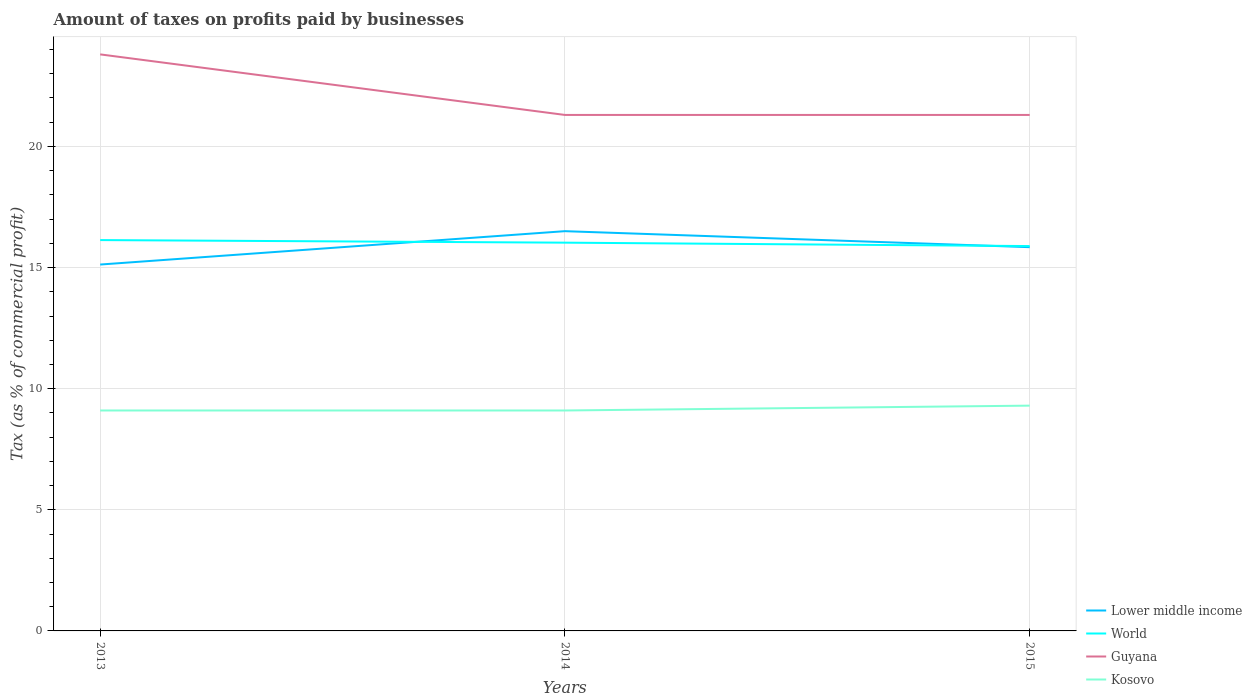Is the number of lines equal to the number of legend labels?
Your response must be concise. Yes. Across all years, what is the maximum percentage of taxes paid by businesses in Guyana?
Give a very brief answer. 21.3. What is the total percentage of taxes paid by businesses in Lower middle income in the graph?
Provide a succinct answer. 0.66. What is the difference between the highest and the second highest percentage of taxes paid by businesses in World?
Make the answer very short. 0.25. What is the difference between the highest and the lowest percentage of taxes paid by businesses in World?
Give a very brief answer. 2. Are the values on the major ticks of Y-axis written in scientific E-notation?
Provide a succinct answer. No. Where does the legend appear in the graph?
Provide a succinct answer. Bottom right. How many legend labels are there?
Offer a terse response. 4. What is the title of the graph?
Provide a succinct answer. Amount of taxes on profits paid by businesses. Does "Tunisia" appear as one of the legend labels in the graph?
Your answer should be very brief. No. What is the label or title of the X-axis?
Provide a succinct answer. Years. What is the label or title of the Y-axis?
Offer a terse response. Tax (as % of commercial profit). What is the Tax (as % of commercial profit) in Lower middle income in 2013?
Give a very brief answer. 15.12. What is the Tax (as % of commercial profit) in World in 2013?
Make the answer very short. 16.13. What is the Tax (as % of commercial profit) of Guyana in 2013?
Make the answer very short. 23.8. What is the Tax (as % of commercial profit) of Kosovo in 2013?
Ensure brevity in your answer.  9.1. What is the Tax (as % of commercial profit) of Lower middle income in 2014?
Provide a short and direct response. 16.5. What is the Tax (as % of commercial profit) of World in 2014?
Provide a succinct answer. 16.03. What is the Tax (as % of commercial profit) in Guyana in 2014?
Offer a terse response. 21.3. What is the Tax (as % of commercial profit) in Lower middle income in 2015?
Your response must be concise. 15.84. What is the Tax (as % of commercial profit) of World in 2015?
Give a very brief answer. 15.89. What is the Tax (as % of commercial profit) in Guyana in 2015?
Give a very brief answer. 21.3. Across all years, what is the maximum Tax (as % of commercial profit) in Lower middle income?
Your answer should be very brief. 16.5. Across all years, what is the maximum Tax (as % of commercial profit) in World?
Your answer should be very brief. 16.13. Across all years, what is the maximum Tax (as % of commercial profit) in Guyana?
Keep it short and to the point. 23.8. Across all years, what is the maximum Tax (as % of commercial profit) of Kosovo?
Keep it short and to the point. 9.3. Across all years, what is the minimum Tax (as % of commercial profit) of Lower middle income?
Provide a succinct answer. 15.12. Across all years, what is the minimum Tax (as % of commercial profit) in World?
Give a very brief answer. 15.89. Across all years, what is the minimum Tax (as % of commercial profit) of Guyana?
Your answer should be compact. 21.3. Across all years, what is the minimum Tax (as % of commercial profit) in Kosovo?
Your answer should be very brief. 9.1. What is the total Tax (as % of commercial profit) in Lower middle income in the graph?
Make the answer very short. 47.47. What is the total Tax (as % of commercial profit) in World in the graph?
Provide a short and direct response. 48.05. What is the total Tax (as % of commercial profit) in Guyana in the graph?
Offer a very short reply. 66.4. What is the total Tax (as % of commercial profit) of Kosovo in the graph?
Ensure brevity in your answer.  27.5. What is the difference between the Tax (as % of commercial profit) of Lower middle income in 2013 and that in 2014?
Give a very brief answer. -1.38. What is the difference between the Tax (as % of commercial profit) in World in 2013 and that in 2014?
Keep it short and to the point. 0.11. What is the difference between the Tax (as % of commercial profit) in Guyana in 2013 and that in 2014?
Offer a very short reply. 2.5. What is the difference between the Tax (as % of commercial profit) in Lower middle income in 2013 and that in 2015?
Provide a short and direct response. -0.72. What is the difference between the Tax (as % of commercial profit) in World in 2013 and that in 2015?
Provide a succinct answer. 0.25. What is the difference between the Tax (as % of commercial profit) in Kosovo in 2013 and that in 2015?
Make the answer very short. -0.2. What is the difference between the Tax (as % of commercial profit) of Lower middle income in 2014 and that in 2015?
Ensure brevity in your answer.  0.66. What is the difference between the Tax (as % of commercial profit) of World in 2014 and that in 2015?
Offer a very short reply. 0.14. What is the difference between the Tax (as % of commercial profit) of Kosovo in 2014 and that in 2015?
Offer a very short reply. -0.2. What is the difference between the Tax (as % of commercial profit) of Lower middle income in 2013 and the Tax (as % of commercial profit) of World in 2014?
Offer a very short reply. -0.9. What is the difference between the Tax (as % of commercial profit) of Lower middle income in 2013 and the Tax (as % of commercial profit) of Guyana in 2014?
Provide a short and direct response. -6.18. What is the difference between the Tax (as % of commercial profit) in Lower middle income in 2013 and the Tax (as % of commercial profit) in Kosovo in 2014?
Your answer should be very brief. 6.02. What is the difference between the Tax (as % of commercial profit) in World in 2013 and the Tax (as % of commercial profit) in Guyana in 2014?
Provide a succinct answer. -5.17. What is the difference between the Tax (as % of commercial profit) of World in 2013 and the Tax (as % of commercial profit) of Kosovo in 2014?
Provide a short and direct response. 7.03. What is the difference between the Tax (as % of commercial profit) in Guyana in 2013 and the Tax (as % of commercial profit) in Kosovo in 2014?
Your answer should be very brief. 14.7. What is the difference between the Tax (as % of commercial profit) in Lower middle income in 2013 and the Tax (as % of commercial profit) in World in 2015?
Provide a short and direct response. -0.76. What is the difference between the Tax (as % of commercial profit) in Lower middle income in 2013 and the Tax (as % of commercial profit) in Guyana in 2015?
Your answer should be compact. -6.18. What is the difference between the Tax (as % of commercial profit) of Lower middle income in 2013 and the Tax (as % of commercial profit) of Kosovo in 2015?
Ensure brevity in your answer.  5.82. What is the difference between the Tax (as % of commercial profit) in World in 2013 and the Tax (as % of commercial profit) in Guyana in 2015?
Ensure brevity in your answer.  -5.17. What is the difference between the Tax (as % of commercial profit) in World in 2013 and the Tax (as % of commercial profit) in Kosovo in 2015?
Your answer should be very brief. 6.83. What is the difference between the Tax (as % of commercial profit) in Guyana in 2013 and the Tax (as % of commercial profit) in Kosovo in 2015?
Give a very brief answer. 14.5. What is the difference between the Tax (as % of commercial profit) of Lower middle income in 2014 and the Tax (as % of commercial profit) of World in 2015?
Give a very brief answer. 0.62. What is the difference between the Tax (as % of commercial profit) in Lower middle income in 2014 and the Tax (as % of commercial profit) in Guyana in 2015?
Your answer should be compact. -4.8. What is the difference between the Tax (as % of commercial profit) of Lower middle income in 2014 and the Tax (as % of commercial profit) of Kosovo in 2015?
Your answer should be compact. 7.2. What is the difference between the Tax (as % of commercial profit) in World in 2014 and the Tax (as % of commercial profit) in Guyana in 2015?
Ensure brevity in your answer.  -5.27. What is the difference between the Tax (as % of commercial profit) in World in 2014 and the Tax (as % of commercial profit) in Kosovo in 2015?
Give a very brief answer. 6.73. What is the difference between the Tax (as % of commercial profit) in Guyana in 2014 and the Tax (as % of commercial profit) in Kosovo in 2015?
Offer a very short reply. 12. What is the average Tax (as % of commercial profit) of Lower middle income per year?
Make the answer very short. 15.82. What is the average Tax (as % of commercial profit) of World per year?
Offer a terse response. 16.02. What is the average Tax (as % of commercial profit) of Guyana per year?
Give a very brief answer. 22.13. What is the average Tax (as % of commercial profit) of Kosovo per year?
Provide a short and direct response. 9.17. In the year 2013, what is the difference between the Tax (as % of commercial profit) in Lower middle income and Tax (as % of commercial profit) in World?
Offer a terse response. -1.01. In the year 2013, what is the difference between the Tax (as % of commercial profit) in Lower middle income and Tax (as % of commercial profit) in Guyana?
Your response must be concise. -8.68. In the year 2013, what is the difference between the Tax (as % of commercial profit) in Lower middle income and Tax (as % of commercial profit) in Kosovo?
Give a very brief answer. 6.02. In the year 2013, what is the difference between the Tax (as % of commercial profit) of World and Tax (as % of commercial profit) of Guyana?
Your response must be concise. -7.67. In the year 2013, what is the difference between the Tax (as % of commercial profit) of World and Tax (as % of commercial profit) of Kosovo?
Ensure brevity in your answer.  7.03. In the year 2013, what is the difference between the Tax (as % of commercial profit) of Guyana and Tax (as % of commercial profit) of Kosovo?
Keep it short and to the point. 14.7. In the year 2014, what is the difference between the Tax (as % of commercial profit) of Lower middle income and Tax (as % of commercial profit) of World?
Offer a terse response. 0.47. In the year 2014, what is the difference between the Tax (as % of commercial profit) of Lower middle income and Tax (as % of commercial profit) of Guyana?
Keep it short and to the point. -4.8. In the year 2014, what is the difference between the Tax (as % of commercial profit) of Lower middle income and Tax (as % of commercial profit) of Kosovo?
Keep it short and to the point. 7.4. In the year 2014, what is the difference between the Tax (as % of commercial profit) of World and Tax (as % of commercial profit) of Guyana?
Give a very brief answer. -5.27. In the year 2014, what is the difference between the Tax (as % of commercial profit) of World and Tax (as % of commercial profit) of Kosovo?
Provide a succinct answer. 6.93. In the year 2015, what is the difference between the Tax (as % of commercial profit) in Lower middle income and Tax (as % of commercial profit) in World?
Offer a terse response. -0.05. In the year 2015, what is the difference between the Tax (as % of commercial profit) in Lower middle income and Tax (as % of commercial profit) in Guyana?
Offer a terse response. -5.46. In the year 2015, what is the difference between the Tax (as % of commercial profit) in Lower middle income and Tax (as % of commercial profit) in Kosovo?
Ensure brevity in your answer.  6.54. In the year 2015, what is the difference between the Tax (as % of commercial profit) of World and Tax (as % of commercial profit) of Guyana?
Your response must be concise. -5.41. In the year 2015, what is the difference between the Tax (as % of commercial profit) of World and Tax (as % of commercial profit) of Kosovo?
Provide a succinct answer. 6.59. In the year 2015, what is the difference between the Tax (as % of commercial profit) of Guyana and Tax (as % of commercial profit) of Kosovo?
Your answer should be very brief. 12. What is the ratio of the Tax (as % of commercial profit) of Lower middle income in 2013 to that in 2014?
Make the answer very short. 0.92. What is the ratio of the Tax (as % of commercial profit) in World in 2013 to that in 2014?
Ensure brevity in your answer.  1.01. What is the ratio of the Tax (as % of commercial profit) in Guyana in 2013 to that in 2014?
Offer a terse response. 1.12. What is the ratio of the Tax (as % of commercial profit) of Lower middle income in 2013 to that in 2015?
Your answer should be compact. 0.95. What is the ratio of the Tax (as % of commercial profit) of World in 2013 to that in 2015?
Your answer should be compact. 1.02. What is the ratio of the Tax (as % of commercial profit) in Guyana in 2013 to that in 2015?
Your answer should be compact. 1.12. What is the ratio of the Tax (as % of commercial profit) of Kosovo in 2013 to that in 2015?
Make the answer very short. 0.98. What is the ratio of the Tax (as % of commercial profit) in Lower middle income in 2014 to that in 2015?
Your response must be concise. 1.04. What is the ratio of the Tax (as % of commercial profit) in World in 2014 to that in 2015?
Provide a short and direct response. 1.01. What is the ratio of the Tax (as % of commercial profit) in Guyana in 2014 to that in 2015?
Make the answer very short. 1. What is the ratio of the Tax (as % of commercial profit) in Kosovo in 2014 to that in 2015?
Provide a succinct answer. 0.98. What is the difference between the highest and the second highest Tax (as % of commercial profit) in Lower middle income?
Offer a terse response. 0.66. What is the difference between the highest and the second highest Tax (as % of commercial profit) in World?
Offer a very short reply. 0.11. What is the difference between the highest and the lowest Tax (as % of commercial profit) of Lower middle income?
Provide a succinct answer. 1.38. What is the difference between the highest and the lowest Tax (as % of commercial profit) of World?
Provide a short and direct response. 0.25. What is the difference between the highest and the lowest Tax (as % of commercial profit) in Guyana?
Your answer should be compact. 2.5. 